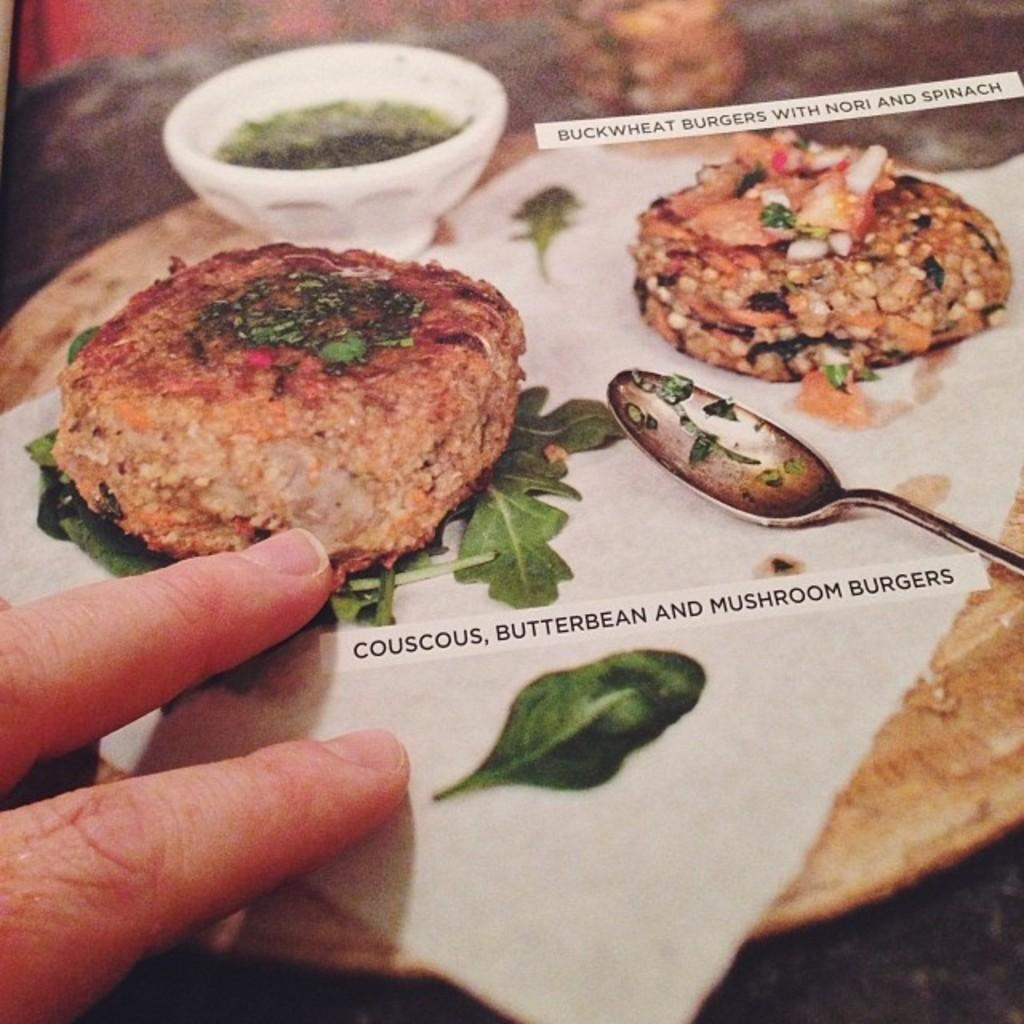What body part can be seen in the image? There are fingers visible in the image. What is the person holding in the image? There is a spoon in the image. What type of food is present in the image? There is food in the image. What is the food placed on in the image? There is a bowl in the image. What type of vegetation is present in the image? There are vegetable leaves in the image. What type of material is present in the image? There is paper in the image. Is there any text visible in the image? Yes, there is some text visible in the image. Can you tell me how many toads are sitting on the bowl in the image? There are no toads present in the image; it features fingers, a spoon, food, vegetable leaves, paper, and text. What type of powder is sprinkled on the food in the image? There is no powder present on the food in the image. 